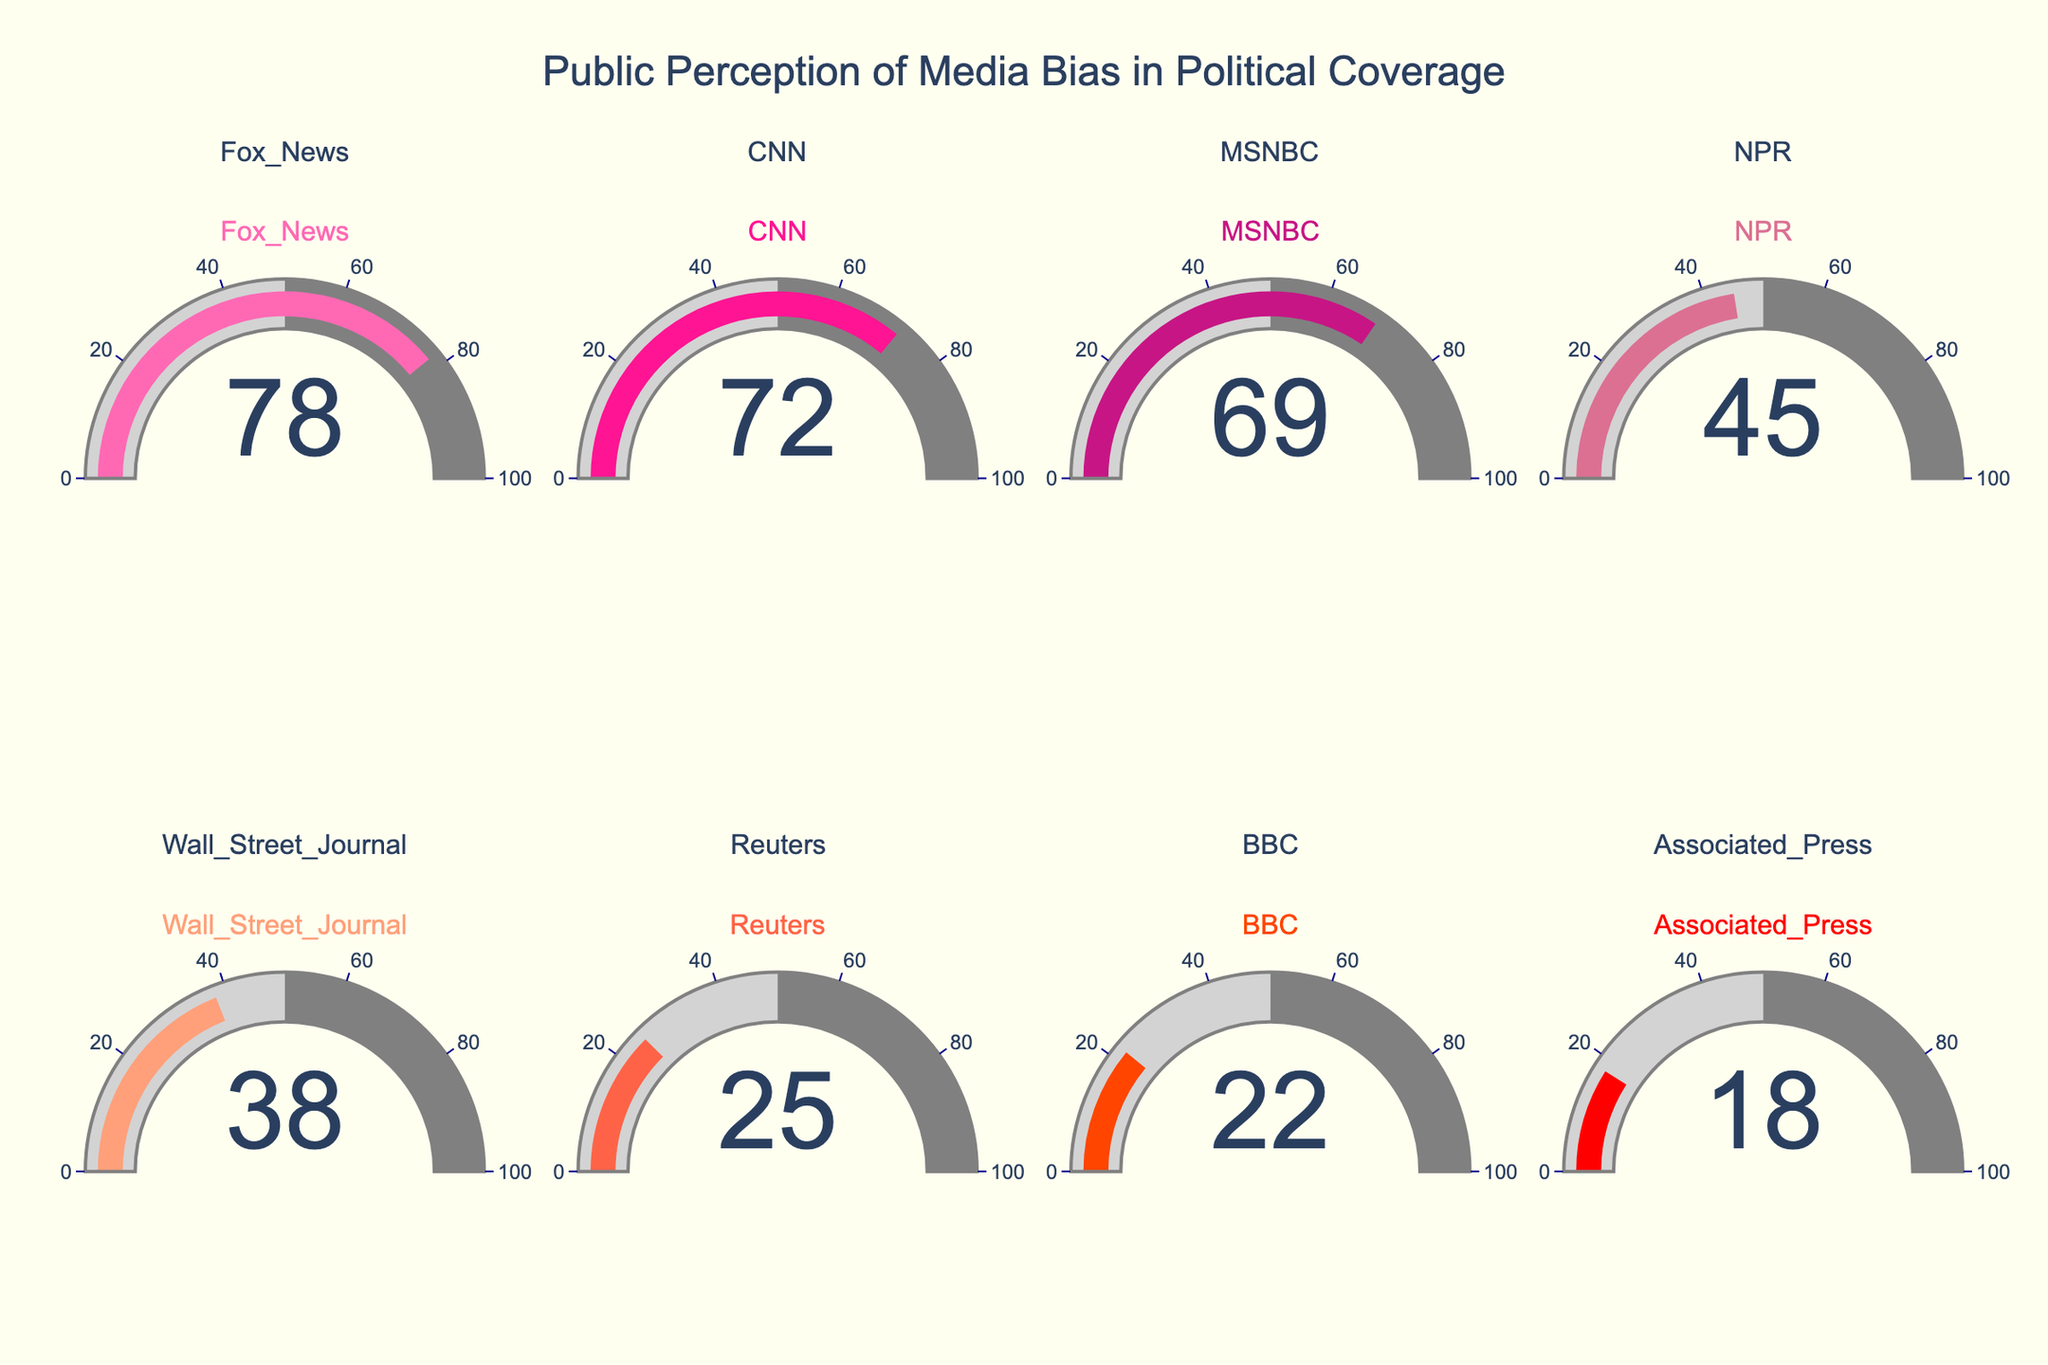Which media outlet has the highest perceived bias score? The figure shows gauge charts for each media outlet with corresponding bias scores. By visually identifying the highest value, Fox News has the highest perceived bias score of 78.
Answer: Fox News What is the title of the figure? The title is located at the top center of the figure and typically provides an overview of the data being represented. The title reads "Public Perception of Media Bias in Political Coverage."
Answer: Public Perception of Media Bias in Political Coverage How many media outlets are represented in the gauge charts? By counting the number of gauge charts displayed in the figure, we see eight media outlets represented.
Answer: 8 Which media outlet is perceived to have the least bias? By visually scanning the gauge charts for the lowest score, Associated Press has the lowest perceived bias score of 18.
Answer: Associated Press What is the average perceived bias score of all media outlets? To calculate the average, sum all the perceived bias scores: (78 + 72 + 69 + 45 + 38 + 25 + 22 + 18) = 367, then divide by the number of media outlets, which is 8. Therefore, 367 / 8 = 45.875.
Answer: 45.875 What is the difference in perceived bias scores between CNN and NPR? By looking at the scores: CNN has 72 and NPR has 45. The difference is 72 - 45 = 27.
Answer: 27 Which media outlet is just below MSNBC in terms of perceived bias score? By identifying the score just below MSNBC (69), we find NPR with a score of 45.
Answer: NPR What are the colors used for the media outlets in the gauge charts? The figure uses different shades of red and pink. Specifically starting from pink (#FF69B4) to red (#FF0000) for various media outlets.
Answer: Pink to red shades If the media bias score for all outlets increased by 10 points, what would be the new score for Wall Street Journal? Wall Street Journal originally has a score of 38. If it increases by 10 points, the new score would be 38 + 10 = 48.
Answer: 48 